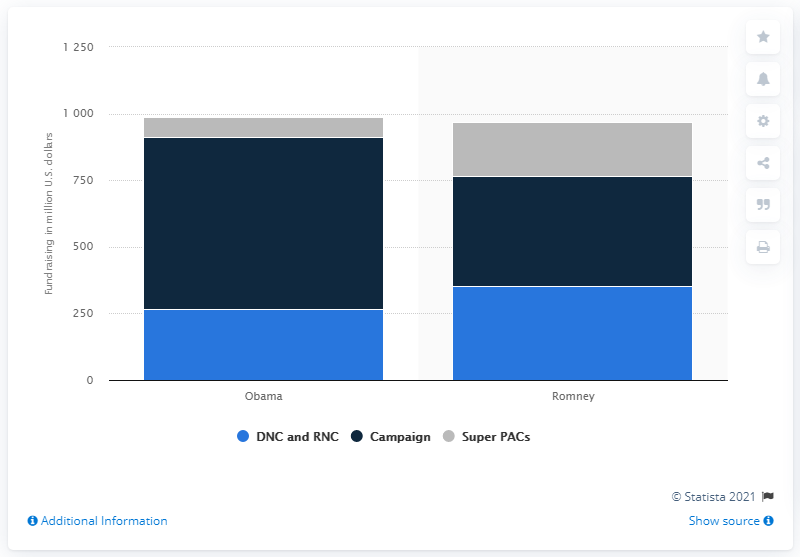Draw attention to some important aspects in this diagram. The Obama campaign has raised $645. 